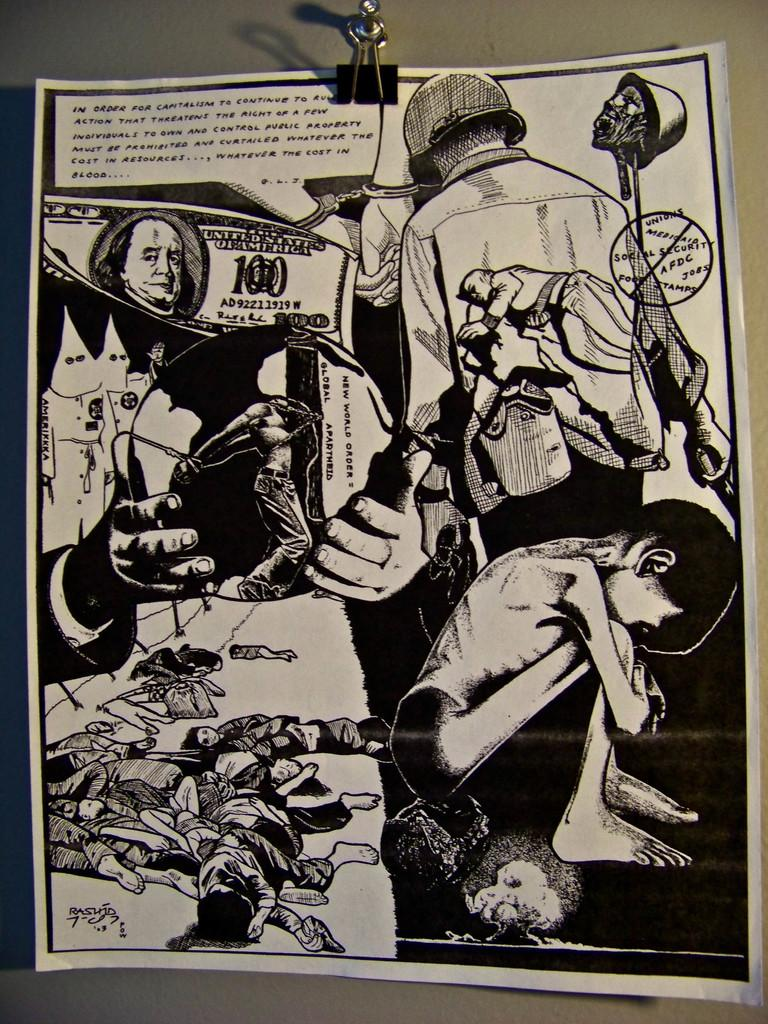<image>
Relay a brief, clear account of the picture shown. Page from a comic book with a 100 dollar bill on it. 